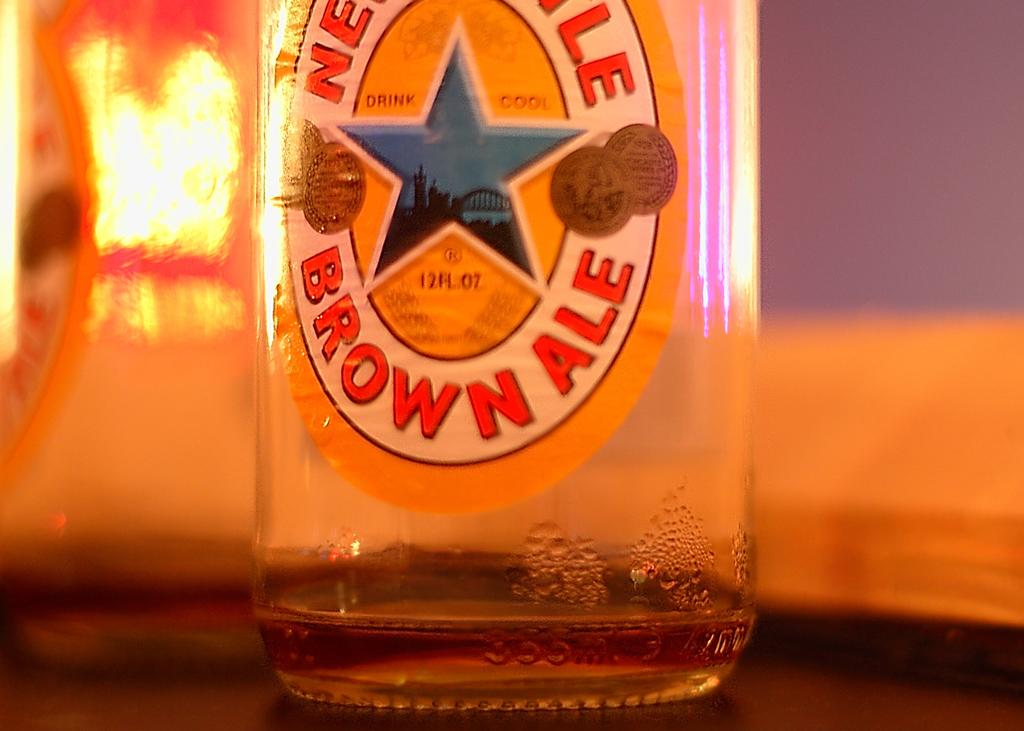Provide a one-sentence caption for the provided image. A Brown Ale bottle has a blue star on the center of the label. 